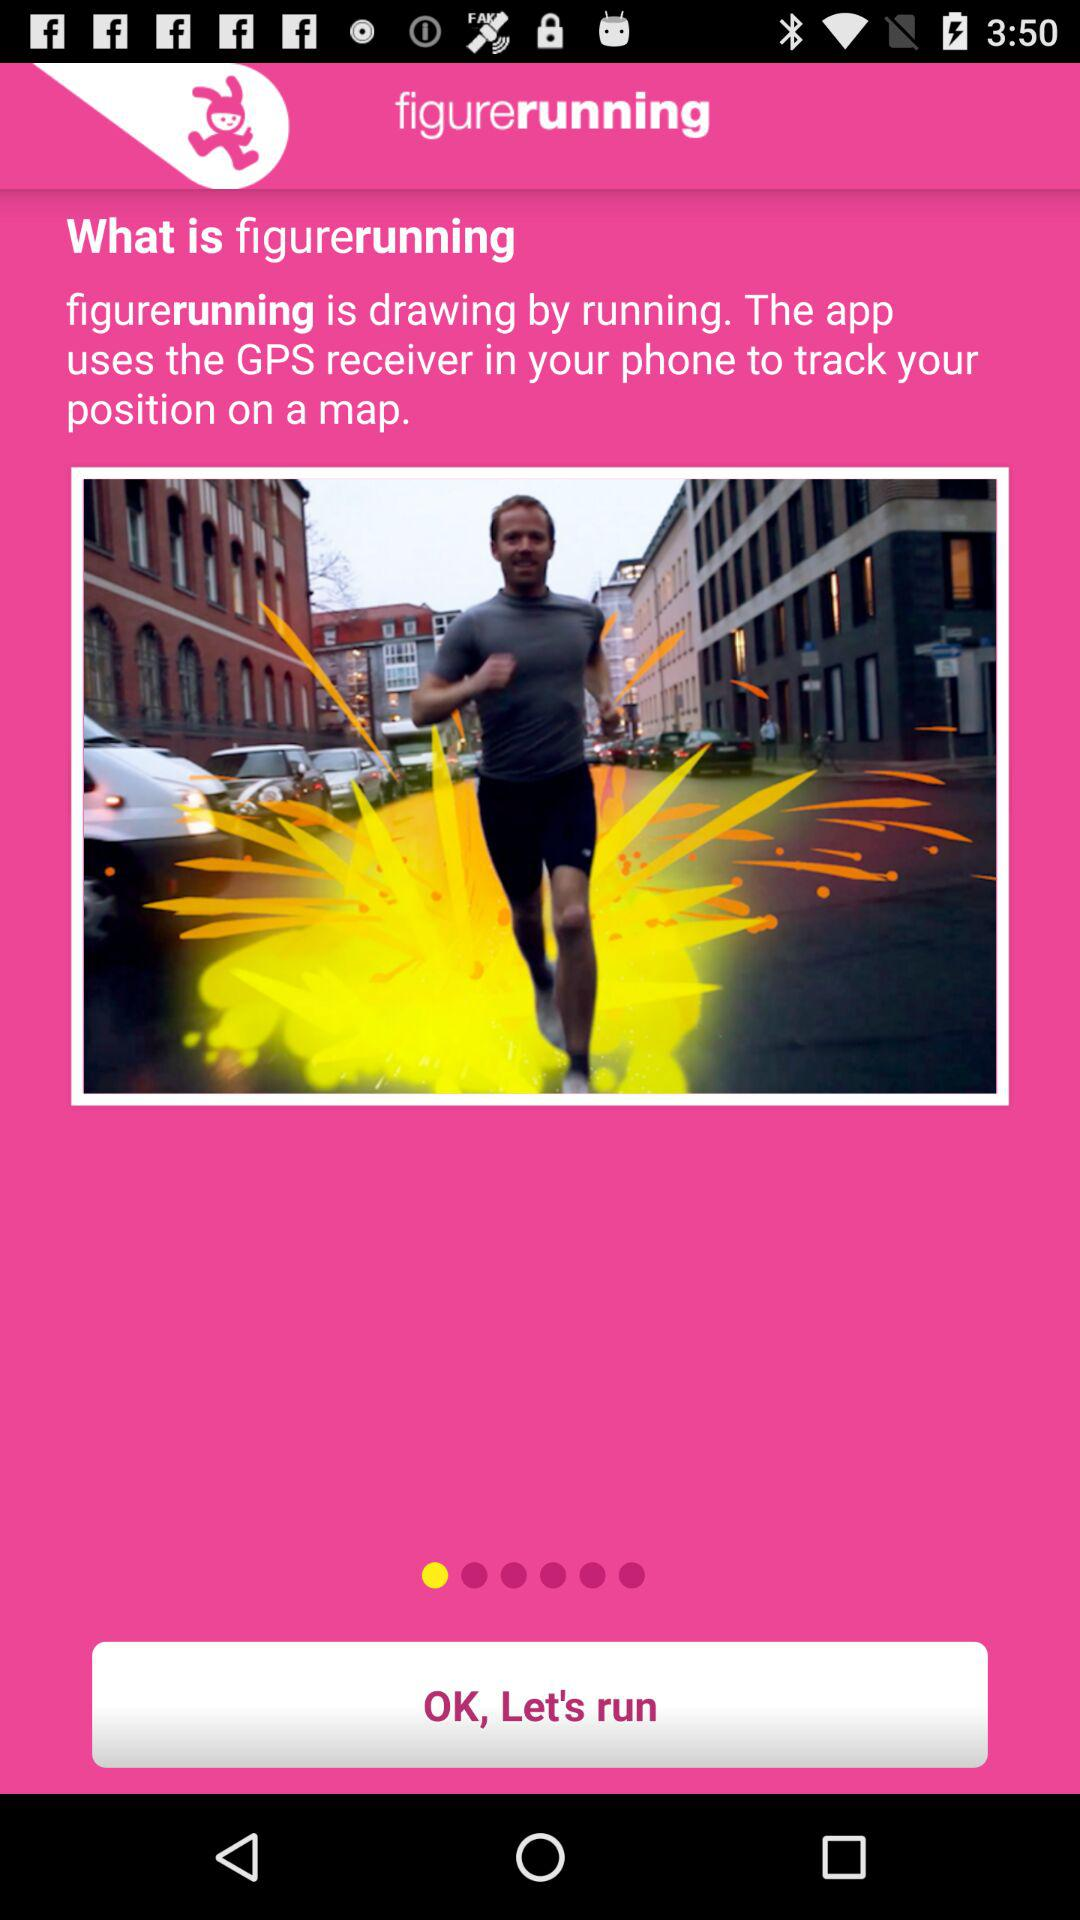What is figurerunning? Figurerunning is drawing by running. 